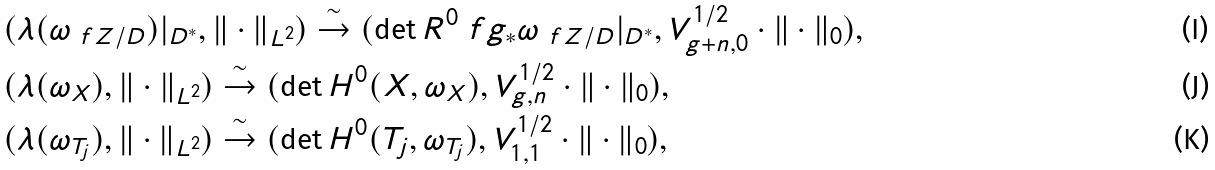<formula> <loc_0><loc_0><loc_500><loc_500>& ( \lambda ( \omega _ { \ f Z / D } ) | _ { D ^ { \ast } } , \| \cdot \| _ { L ^ { 2 } } ) \overset { \sim } { \rightarrow } ( \det R ^ { 0 } \ f g _ { \ast } \omega _ { \ f Z / D } | _ { D ^ { \ast } } , V _ { g + n , 0 } ^ { 1 / 2 } \cdot \| \cdot \| _ { 0 } ) , \\ & ( \lambda ( \omega _ { X } ) , \| \cdot \| _ { L ^ { 2 } } ) \overset { \sim } { \rightarrow } ( \det H ^ { 0 } ( X , \omega _ { X } ) , V _ { g , n } ^ { 1 / 2 } \cdot \| \cdot \| _ { 0 } ) , \\ & ( \lambda ( \omega _ { T _ { j } } ) , \| \cdot \| _ { L ^ { 2 } } ) \overset { \sim } { \rightarrow } ( \det H ^ { 0 } ( T _ { j } , \omega _ { T _ { j } } ) , V _ { 1 , 1 } ^ { 1 / 2 } \cdot \| \cdot \| _ { 0 } ) ,</formula> 